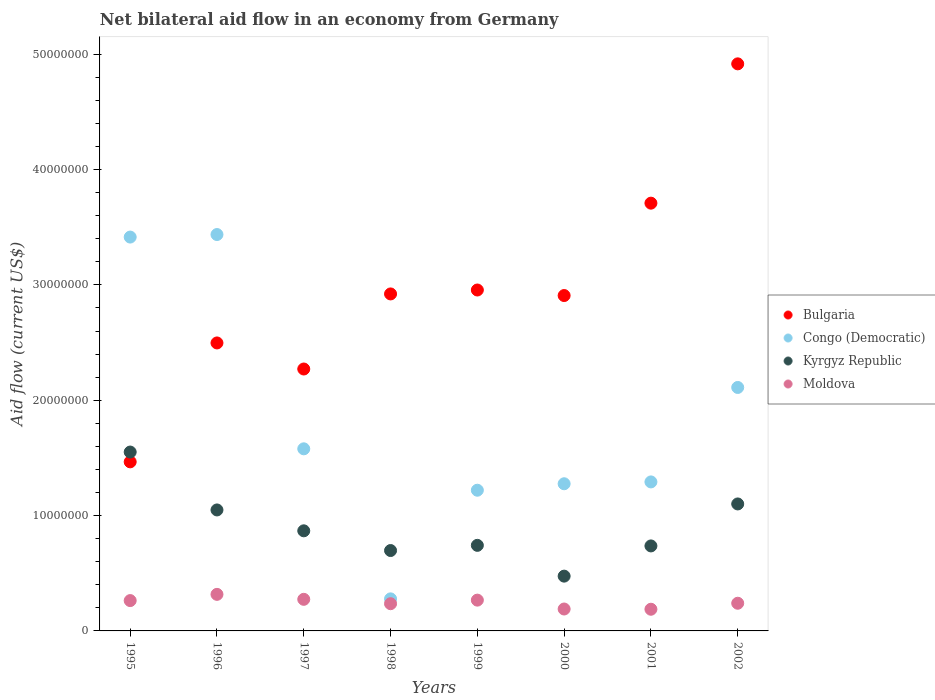What is the net bilateral aid flow in Bulgaria in 1999?
Your answer should be very brief. 2.96e+07. Across all years, what is the maximum net bilateral aid flow in Moldova?
Your response must be concise. 3.17e+06. Across all years, what is the minimum net bilateral aid flow in Congo (Democratic)?
Offer a terse response. 2.78e+06. In which year was the net bilateral aid flow in Moldova minimum?
Keep it short and to the point. 2001. What is the total net bilateral aid flow in Congo (Democratic) in the graph?
Provide a short and direct response. 1.46e+08. What is the difference between the net bilateral aid flow in Congo (Democratic) in 1999 and that in 2000?
Your response must be concise. -5.60e+05. What is the difference between the net bilateral aid flow in Kyrgyz Republic in 2002 and the net bilateral aid flow in Moldova in 2001?
Your response must be concise. 9.13e+06. What is the average net bilateral aid flow in Bulgaria per year?
Offer a terse response. 2.96e+07. In the year 2002, what is the difference between the net bilateral aid flow in Bulgaria and net bilateral aid flow in Kyrgyz Republic?
Give a very brief answer. 3.82e+07. In how many years, is the net bilateral aid flow in Bulgaria greater than 42000000 US$?
Offer a very short reply. 1. What is the ratio of the net bilateral aid flow in Congo (Democratic) in 1999 to that in 2000?
Keep it short and to the point. 0.96. Is the net bilateral aid flow in Kyrgyz Republic in 1995 less than that in 1998?
Make the answer very short. No. What is the difference between the highest and the lowest net bilateral aid flow in Bulgaria?
Provide a short and direct response. 3.45e+07. In how many years, is the net bilateral aid flow in Kyrgyz Republic greater than the average net bilateral aid flow in Kyrgyz Republic taken over all years?
Your answer should be very brief. 3. Is the sum of the net bilateral aid flow in Congo (Democratic) in 1995 and 1997 greater than the maximum net bilateral aid flow in Moldova across all years?
Your answer should be very brief. Yes. Is the net bilateral aid flow in Moldova strictly greater than the net bilateral aid flow in Bulgaria over the years?
Provide a succinct answer. No. Is the net bilateral aid flow in Kyrgyz Republic strictly less than the net bilateral aid flow in Bulgaria over the years?
Give a very brief answer. No. What is the difference between two consecutive major ticks on the Y-axis?
Your answer should be compact. 1.00e+07. How many legend labels are there?
Provide a short and direct response. 4. What is the title of the graph?
Provide a succinct answer. Net bilateral aid flow in an economy from Germany. What is the label or title of the X-axis?
Offer a terse response. Years. What is the Aid flow (current US$) in Bulgaria in 1995?
Your response must be concise. 1.47e+07. What is the Aid flow (current US$) in Congo (Democratic) in 1995?
Offer a very short reply. 3.42e+07. What is the Aid flow (current US$) in Kyrgyz Republic in 1995?
Ensure brevity in your answer.  1.55e+07. What is the Aid flow (current US$) of Moldova in 1995?
Offer a terse response. 2.63e+06. What is the Aid flow (current US$) in Bulgaria in 1996?
Provide a succinct answer. 2.50e+07. What is the Aid flow (current US$) of Congo (Democratic) in 1996?
Offer a very short reply. 3.44e+07. What is the Aid flow (current US$) of Kyrgyz Republic in 1996?
Give a very brief answer. 1.05e+07. What is the Aid flow (current US$) in Moldova in 1996?
Provide a succinct answer. 3.17e+06. What is the Aid flow (current US$) in Bulgaria in 1997?
Ensure brevity in your answer.  2.27e+07. What is the Aid flow (current US$) of Congo (Democratic) in 1997?
Offer a terse response. 1.58e+07. What is the Aid flow (current US$) in Kyrgyz Republic in 1997?
Offer a terse response. 8.68e+06. What is the Aid flow (current US$) in Moldova in 1997?
Your answer should be very brief. 2.74e+06. What is the Aid flow (current US$) in Bulgaria in 1998?
Your response must be concise. 2.92e+07. What is the Aid flow (current US$) in Congo (Democratic) in 1998?
Give a very brief answer. 2.78e+06. What is the Aid flow (current US$) of Kyrgyz Republic in 1998?
Give a very brief answer. 6.97e+06. What is the Aid flow (current US$) of Moldova in 1998?
Your answer should be very brief. 2.36e+06. What is the Aid flow (current US$) of Bulgaria in 1999?
Offer a terse response. 2.96e+07. What is the Aid flow (current US$) of Congo (Democratic) in 1999?
Make the answer very short. 1.22e+07. What is the Aid flow (current US$) in Kyrgyz Republic in 1999?
Your response must be concise. 7.42e+06. What is the Aid flow (current US$) of Moldova in 1999?
Offer a terse response. 2.67e+06. What is the Aid flow (current US$) in Bulgaria in 2000?
Offer a very short reply. 2.91e+07. What is the Aid flow (current US$) in Congo (Democratic) in 2000?
Provide a short and direct response. 1.28e+07. What is the Aid flow (current US$) of Kyrgyz Republic in 2000?
Offer a very short reply. 4.75e+06. What is the Aid flow (current US$) of Moldova in 2000?
Keep it short and to the point. 1.90e+06. What is the Aid flow (current US$) in Bulgaria in 2001?
Keep it short and to the point. 3.71e+07. What is the Aid flow (current US$) of Congo (Democratic) in 2001?
Keep it short and to the point. 1.29e+07. What is the Aid flow (current US$) in Kyrgyz Republic in 2001?
Make the answer very short. 7.37e+06. What is the Aid flow (current US$) in Moldova in 2001?
Your response must be concise. 1.88e+06. What is the Aid flow (current US$) of Bulgaria in 2002?
Your answer should be very brief. 4.92e+07. What is the Aid flow (current US$) in Congo (Democratic) in 2002?
Your answer should be very brief. 2.11e+07. What is the Aid flow (current US$) of Kyrgyz Republic in 2002?
Offer a terse response. 1.10e+07. What is the Aid flow (current US$) of Moldova in 2002?
Give a very brief answer. 2.40e+06. Across all years, what is the maximum Aid flow (current US$) in Bulgaria?
Provide a short and direct response. 4.92e+07. Across all years, what is the maximum Aid flow (current US$) of Congo (Democratic)?
Your response must be concise. 3.44e+07. Across all years, what is the maximum Aid flow (current US$) of Kyrgyz Republic?
Give a very brief answer. 1.55e+07. Across all years, what is the maximum Aid flow (current US$) of Moldova?
Your answer should be compact. 3.17e+06. Across all years, what is the minimum Aid flow (current US$) in Bulgaria?
Make the answer very short. 1.47e+07. Across all years, what is the minimum Aid flow (current US$) of Congo (Democratic)?
Offer a very short reply. 2.78e+06. Across all years, what is the minimum Aid flow (current US$) in Kyrgyz Republic?
Make the answer very short. 4.75e+06. Across all years, what is the minimum Aid flow (current US$) of Moldova?
Offer a terse response. 1.88e+06. What is the total Aid flow (current US$) of Bulgaria in the graph?
Ensure brevity in your answer.  2.36e+08. What is the total Aid flow (current US$) of Congo (Democratic) in the graph?
Provide a short and direct response. 1.46e+08. What is the total Aid flow (current US$) in Kyrgyz Republic in the graph?
Keep it short and to the point. 7.22e+07. What is the total Aid flow (current US$) in Moldova in the graph?
Your answer should be very brief. 1.98e+07. What is the difference between the Aid flow (current US$) of Bulgaria in 1995 and that in 1996?
Offer a terse response. -1.03e+07. What is the difference between the Aid flow (current US$) in Congo (Democratic) in 1995 and that in 1996?
Ensure brevity in your answer.  -2.20e+05. What is the difference between the Aid flow (current US$) in Kyrgyz Republic in 1995 and that in 1996?
Your answer should be compact. 5.02e+06. What is the difference between the Aid flow (current US$) of Moldova in 1995 and that in 1996?
Your response must be concise. -5.40e+05. What is the difference between the Aid flow (current US$) in Bulgaria in 1995 and that in 1997?
Ensure brevity in your answer.  -8.05e+06. What is the difference between the Aid flow (current US$) of Congo (Democratic) in 1995 and that in 1997?
Keep it short and to the point. 1.84e+07. What is the difference between the Aid flow (current US$) of Kyrgyz Republic in 1995 and that in 1997?
Provide a succinct answer. 6.83e+06. What is the difference between the Aid flow (current US$) in Moldova in 1995 and that in 1997?
Give a very brief answer. -1.10e+05. What is the difference between the Aid flow (current US$) in Bulgaria in 1995 and that in 1998?
Provide a succinct answer. -1.46e+07. What is the difference between the Aid flow (current US$) in Congo (Democratic) in 1995 and that in 1998?
Offer a very short reply. 3.14e+07. What is the difference between the Aid flow (current US$) in Kyrgyz Republic in 1995 and that in 1998?
Provide a succinct answer. 8.54e+06. What is the difference between the Aid flow (current US$) of Bulgaria in 1995 and that in 1999?
Make the answer very short. -1.49e+07. What is the difference between the Aid flow (current US$) of Congo (Democratic) in 1995 and that in 1999?
Give a very brief answer. 2.20e+07. What is the difference between the Aid flow (current US$) in Kyrgyz Republic in 1995 and that in 1999?
Your answer should be very brief. 8.09e+06. What is the difference between the Aid flow (current US$) of Moldova in 1995 and that in 1999?
Your response must be concise. -4.00e+04. What is the difference between the Aid flow (current US$) in Bulgaria in 1995 and that in 2000?
Your answer should be very brief. -1.44e+07. What is the difference between the Aid flow (current US$) of Congo (Democratic) in 1995 and that in 2000?
Ensure brevity in your answer.  2.14e+07. What is the difference between the Aid flow (current US$) of Kyrgyz Republic in 1995 and that in 2000?
Offer a terse response. 1.08e+07. What is the difference between the Aid flow (current US$) in Moldova in 1995 and that in 2000?
Give a very brief answer. 7.30e+05. What is the difference between the Aid flow (current US$) in Bulgaria in 1995 and that in 2001?
Your response must be concise. -2.24e+07. What is the difference between the Aid flow (current US$) of Congo (Democratic) in 1995 and that in 2001?
Offer a terse response. 2.12e+07. What is the difference between the Aid flow (current US$) of Kyrgyz Republic in 1995 and that in 2001?
Ensure brevity in your answer.  8.14e+06. What is the difference between the Aid flow (current US$) in Moldova in 1995 and that in 2001?
Give a very brief answer. 7.50e+05. What is the difference between the Aid flow (current US$) in Bulgaria in 1995 and that in 2002?
Your answer should be compact. -3.45e+07. What is the difference between the Aid flow (current US$) in Congo (Democratic) in 1995 and that in 2002?
Keep it short and to the point. 1.30e+07. What is the difference between the Aid flow (current US$) in Kyrgyz Republic in 1995 and that in 2002?
Offer a terse response. 4.50e+06. What is the difference between the Aid flow (current US$) in Bulgaria in 1996 and that in 1997?
Provide a succinct answer. 2.26e+06. What is the difference between the Aid flow (current US$) of Congo (Democratic) in 1996 and that in 1997?
Your answer should be compact. 1.86e+07. What is the difference between the Aid flow (current US$) of Kyrgyz Republic in 1996 and that in 1997?
Your answer should be very brief. 1.81e+06. What is the difference between the Aid flow (current US$) in Bulgaria in 1996 and that in 1998?
Keep it short and to the point. -4.25e+06. What is the difference between the Aid flow (current US$) in Congo (Democratic) in 1996 and that in 1998?
Offer a terse response. 3.16e+07. What is the difference between the Aid flow (current US$) of Kyrgyz Republic in 1996 and that in 1998?
Provide a short and direct response. 3.52e+06. What is the difference between the Aid flow (current US$) of Moldova in 1996 and that in 1998?
Keep it short and to the point. 8.10e+05. What is the difference between the Aid flow (current US$) in Bulgaria in 1996 and that in 1999?
Keep it short and to the point. -4.59e+06. What is the difference between the Aid flow (current US$) in Congo (Democratic) in 1996 and that in 1999?
Your response must be concise. 2.22e+07. What is the difference between the Aid flow (current US$) of Kyrgyz Republic in 1996 and that in 1999?
Give a very brief answer. 3.07e+06. What is the difference between the Aid flow (current US$) in Moldova in 1996 and that in 1999?
Offer a very short reply. 5.00e+05. What is the difference between the Aid flow (current US$) of Bulgaria in 1996 and that in 2000?
Keep it short and to the point. -4.11e+06. What is the difference between the Aid flow (current US$) in Congo (Democratic) in 1996 and that in 2000?
Provide a succinct answer. 2.16e+07. What is the difference between the Aid flow (current US$) in Kyrgyz Republic in 1996 and that in 2000?
Your answer should be very brief. 5.74e+06. What is the difference between the Aid flow (current US$) in Moldova in 1996 and that in 2000?
Provide a short and direct response. 1.27e+06. What is the difference between the Aid flow (current US$) in Bulgaria in 1996 and that in 2001?
Offer a terse response. -1.21e+07. What is the difference between the Aid flow (current US$) of Congo (Democratic) in 1996 and that in 2001?
Ensure brevity in your answer.  2.14e+07. What is the difference between the Aid flow (current US$) of Kyrgyz Republic in 1996 and that in 2001?
Ensure brevity in your answer.  3.12e+06. What is the difference between the Aid flow (current US$) of Moldova in 1996 and that in 2001?
Your response must be concise. 1.29e+06. What is the difference between the Aid flow (current US$) of Bulgaria in 1996 and that in 2002?
Make the answer very short. -2.42e+07. What is the difference between the Aid flow (current US$) in Congo (Democratic) in 1996 and that in 2002?
Offer a very short reply. 1.33e+07. What is the difference between the Aid flow (current US$) of Kyrgyz Republic in 1996 and that in 2002?
Offer a terse response. -5.20e+05. What is the difference between the Aid flow (current US$) of Moldova in 1996 and that in 2002?
Ensure brevity in your answer.  7.70e+05. What is the difference between the Aid flow (current US$) in Bulgaria in 1997 and that in 1998?
Keep it short and to the point. -6.51e+06. What is the difference between the Aid flow (current US$) of Congo (Democratic) in 1997 and that in 1998?
Give a very brief answer. 1.30e+07. What is the difference between the Aid flow (current US$) of Kyrgyz Republic in 1997 and that in 1998?
Provide a succinct answer. 1.71e+06. What is the difference between the Aid flow (current US$) of Bulgaria in 1997 and that in 1999?
Give a very brief answer. -6.85e+06. What is the difference between the Aid flow (current US$) of Congo (Democratic) in 1997 and that in 1999?
Offer a terse response. 3.59e+06. What is the difference between the Aid flow (current US$) in Kyrgyz Republic in 1997 and that in 1999?
Make the answer very short. 1.26e+06. What is the difference between the Aid flow (current US$) of Moldova in 1997 and that in 1999?
Offer a very short reply. 7.00e+04. What is the difference between the Aid flow (current US$) of Bulgaria in 1997 and that in 2000?
Your response must be concise. -6.37e+06. What is the difference between the Aid flow (current US$) of Congo (Democratic) in 1997 and that in 2000?
Keep it short and to the point. 3.03e+06. What is the difference between the Aid flow (current US$) in Kyrgyz Republic in 1997 and that in 2000?
Offer a very short reply. 3.93e+06. What is the difference between the Aid flow (current US$) in Moldova in 1997 and that in 2000?
Your answer should be compact. 8.40e+05. What is the difference between the Aid flow (current US$) in Bulgaria in 1997 and that in 2001?
Provide a short and direct response. -1.44e+07. What is the difference between the Aid flow (current US$) in Congo (Democratic) in 1997 and that in 2001?
Your answer should be very brief. 2.87e+06. What is the difference between the Aid flow (current US$) in Kyrgyz Republic in 1997 and that in 2001?
Offer a terse response. 1.31e+06. What is the difference between the Aid flow (current US$) of Moldova in 1997 and that in 2001?
Offer a terse response. 8.60e+05. What is the difference between the Aid flow (current US$) of Bulgaria in 1997 and that in 2002?
Provide a succinct answer. -2.65e+07. What is the difference between the Aid flow (current US$) of Congo (Democratic) in 1997 and that in 2002?
Your answer should be compact. -5.32e+06. What is the difference between the Aid flow (current US$) of Kyrgyz Republic in 1997 and that in 2002?
Provide a succinct answer. -2.33e+06. What is the difference between the Aid flow (current US$) in Congo (Democratic) in 1998 and that in 1999?
Make the answer very short. -9.42e+06. What is the difference between the Aid flow (current US$) of Kyrgyz Republic in 1998 and that in 1999?
Offer a terse response. -4.50e+05. What is the difference between the Aid flow (current US$) of Moldova in 1998 and that in 1999?
Offer a very short reply. -3.10e+05. What is the difference between the Aid flow (current US$) in Bulgaria in 1998 and that in 2000?
Your answer should be compact. 1.40e+05. What is the difference between the Aid flow (current US$) in Congo (Democratic) in 1998 and that in 2000?
Your answer should be very brief. -9.98e+06. What is the difference between the Aid flow (current US$) in Kyrgyz Republic in 1998 and that in 2000?
Your response must be concise. 2.22e+06. What is the difference between the Aid flow (current US$) in Bulgaria in 1998 and that in 2001?
Your response must be concise. -7.87e+06. What is the difference between the Aid flow (current US$) in Congo (Democratic) in 1998 and that in 2001?
Your answer should be very brief. -1.01e+07. What is the difference between the Aid flow (current US$) in Kyrgyz Republic in 1998 and that in 2001?
Ensure brevity in your answer.  -4.00e+05. What is the difference between the Aid flow (current US$) in Bulgaria in 1998 and that in 2002?
Make the answer very short. -2.00e+07. What is the difference between the Aid flow (current US$) of Congo (Democratic) in 1998 and that in 2002?
Your response must be concise. -1.83e+07. What is the difference between the Aid flow (current US$) in Kyrgyz Republic in 1998 and that in 2002?
Offer a very short reply. -4.04e+06. What is the difference between the Aid flow (current US$) in Moldova in 1998 and that in 2002?
Your answer should be compact. -4.00e+04. What is the difference between the Aid flow (current US$) in Bulgaria in 1999 and that in 2000?
Your response must be concise. 4.80e+05. What is the difference between the Aid flow (current US$) of Congo (Democratic) in 1999 and that in 2000?
Your answer should be compact. -5.60e+05. What is the difference between the Aid flow (current US$) of Kyrgyz Republic in 1999 and that in 2000?
Ensure brevity in your answer.  2.67e+06. What is the difference between the Aid flow (current US$) of Moldova in 1999 and that in 2000?
Make the answer very short. 7.70e+05. What is the difference between the Aid flow (current US$) of Bulgaria in 1999 and that in 2001?
Make the answer very short. -7.53e+06. What is the difference between the Aid flow (current US$) of Congo (Democratic) in 1999 and that in 2001?
Give a very brief answer. -7.20e+05. What is the difference between the Aid flow (current US$) in Kyrgyz Republic in 1999 and that in 2001?
Provide a succinct answer. 5.00e+04. What is the difference between the Aid flow (current US$) of Moldova in 1999 and that in 2001?
Offer a terse response. 7.90e+05. What is the difference between the Aid flow (current US$) in Bulgaria in 1999 and that in 2002?
Make the answer very short. -1.96e+07. What is the difference between the Aid flow (current US$) of Congo (Democratic) in 1999 and that in 2002?
Offer a very short reply. -8.91e+06. What is the difference between the Aid flow (current US$) in Kyrgyz Republic in 1999 and that in 2002?
Make the answer very short. -3.59e+06. What is the difference between the Aid flow (current US$) in Moldova in 1999 and that in 2002?
Offer a very short reply. 2.70e+05. What is the difference between the Aid flow (current US$) of Bulgaria in 2000 and that in 2001?
Give a very brief answer. -8.01e+06. What is the difference between the Aid flow (current US$) of Congo (Democratic) in 2000 and that in 2001?
Provide a succinct answer. -1.60e+05. What is the difference between the Aid flow (current US$) of Kyrgyz Republic in 2000 and that in 2001?
Make the answer very short. -2.62e+06. What is the difference between the Aid flow (current US$) in Bulgaria in 2000 and that in 2002?
Provide a succinct answer. -2.01e+07. What is the difference between the Aid flow (current US$) of Congo (Democratic) in 2000 and that in 2002?
Ensure brevity in your answer.  -8.35e+06. What is the difference between the Aid flow (current US$) in Kyrgyz Republic in 2000 and that in 2002?
Offer a terse response. -6.26e+06. What is the difference between the Aid flow (current US$) of Moldova in 2000 and that in 2002?
Give a very brief answer. -5.00e+05. What is the difference between the Aid flow (current US$) in Bulgaria in 2001 and that in 2002?
Make the answer very short. -1.21e+07. What is the difference between the Aid flow (current US$) of Congo (Democratic) in 2001 and that in 2002?
Offer a very short reply. -8.19e+06. What is the difference between the Aid flow (current US$) in Kyrgyz Republic in 2001 and that in 2002?
Keep it short and to the point. -3.64e+06. What is the difference between the Aid flow (current US$) in Moldova in 2001 and that in 2002?
Your response must be concise. -5.20e+05. What is the difference between the Aid flow (current US$) of Bulgaria in 1995 and the Aid flow (current US$) of Congo (Democratic) in 1996?
Give a very brief answer. -1.97e+07. What is the difference between the Aid flow (current US$) in Bulgaria in 1995 and the Aid flow (current US$) in Kyrgyz Republic in 1996?
Provide a succinct answer. 4.17e+06. What is the difference between the Aid flow (current US$) in Bulgaria in 1995 and the Aid flow (current US$) in Moldova in 1996?
Provide a short and direct response. 1.15e+07. What is the difference between the Aid flow (current US$) in Congo (Democratic) in 1995 and the Aid flow (current US$) in Kyrgyz Republic in 1996?
Your response must be concise. 2.37e+07. What is the difference between the Aid flow (current US$) of Congo (Democratic) in 1995 and the Aid flow (current US$) of Moldova in 1996?
Offer a very short reply. 3.10e+07. What is the difference between the Aid flow (current US$) of Kyrgyz Republic in 1995 and the Aid flow (current US$) of Moldova in 1996?
Make the answer very short. 1.23e+07. What is the difference between the Aid flow (current US$) in Bulgaria in 1995 and the Aid flow (current US$) in Congo (Democratic) in 1997?
Your answer should be compact. -1.13e+06. What is the difference between the Aid flow (current US$) of Bulgaria in 1995 and the Aid flow (current US$) of Kyrgyz Republic in 1997?
Offer a very short reply. 5.98e+06. What is the difference between the Aid flow (current US$) in Bulgaria in 1995 and the Aid flow (current US$) in Moldova in 1997?
Your answer should be compact. 1.19e+07. What is the difference between the Aid flow (current US$) of Congo (Democratic) in 1995 and the Aid flow (current US$) of Kyrgyz Republic in 1997?
Offer a very short reply. 2.55e+07. What is the difference between the Aid flow (current US$) of Congo (Democratic) in 1995 and the Aid flow (current US$) of Moldova in 1997?
Your answer should be very brief. 3.14e+07. What is the difference between the Aid flow (current US$) in Kyrgyz Republic in 1995 and the Aid flow (current US$) in Moldova in 1997?
Ensure brevity in your answer.  1.28e+07. What is the difference between the Aid flow (current US$) in Bulgaria in 1995 and the Aid flow (current US$) in Congo (Democratic) in 1998?
Provide a short and direct response. 1.19e+07. What is the difference between the Aid flow (current US$) of Bulgaria in 1995 and the Aid flow (current US$) of Kyrgyz Republic in 1998?
Provide a succinct answer. 7.69e+06. What is the difference between the Aid flow (current US$) of Bulgaria in 1995 and the Aid flow (current US$) of Moldova in 1998?
Keep it short and to the point. 1.23e+07. What is the difference between the Aid flow (current US$) in Congo (Democratic) in 1995 and the Aid flow (current US$) in Kyrgyz Republic in 1998?
Offer a very short reply. 2.72e+07. What is the difference between the Aid flow (current US$) in Congo (Democratic) in 1995 and the Aid flow (current US$) in Moldova in 1998?
Offer a very short reply. 3.18e+07. What is the difference between the Aid flow (current US$) in Kyrgyz Republic in 1995 and the Aid flow (current US$) in Moldova in 1998?
Give a very brief answer. 1.32e+07. What is the difference between the Aid flow (current US$) of Bulgaria in 1995 and the Aid flow (current US$) of Congo (Democratic) in 1999?
Ensure brevity in your answer.  2.46e+06. What is the difference between the Aid flow (current US$) of Bulgaria in 1995 and the Aid flow (current US$) of Kyrgyz Republic in 1999?
Offer a terse response. 7.24e+06. What is the difference between the Aid flow (current US$) of Bulgaria in 1995 and the Aid flow (current US$) of Moldova in 1999?
Keep it short and to the point. 1.20e+07. What is the difference between the Aid flow (current US$) in Congo (Democratic) in 1995 and the Aid flow (current US$) in Kyrgyz Republic in 1999?
Your answer should be very brief. 2.67e+07. What is the difference between the Aid flow (current US$) in Congo (Democratic) in 1995 and the Aid flow (current US$) in Moldova in 1999?
Ensure brevity in your answer.  3.15e+07. What is the difference between the Aid flow (current US$) in Kyrgyz Republic in 1995 and the Aid flow (current US$) in Moldova in 1999?
Provide a short and direct response. 1.28e+07. What is the difference between the Aid flow (current US$) of Bulgaria in 1995 and the Aid flow (current US$) of Congo (Democratic) in 2000?
Provide a short and direct response. 1.90e+06. What is the difference between the Aid flow (current US$) of Bulgaria in 1995 and the Aid flow (current US$) of Kyrgyz Republic in 2000?
Give a very brief answer. 9.91e+06. What is the difference between the Aid flow (current US$) in Bulgaria in 1995 and the Aid flow (current US$) in Moldova in 2000?
Your response must be concise. 1.28e+07. What is the difference between the Aid flow (current US$) of Congo (Democratic) in 1995 and the Aid flow (current US$) of Kyrgyz Republic in 2000?
Offer a terse response. 2.94e+07. What is the difference between the Aid flow (current US$) in Congo (Democratic) in 1995 and the Aid flow (current US$) in Moldova in 2000?
Offer a terse response. 3.22e+07. What is the difference between the Aid flow (current US$) in Kyrgyz Republic in 1995 and the Aid flow (current US$) in Moldova in 2000?
Make the answer very short. 1.36e+07. What is the difference between the Aid flow (current US$) in Bulgaria in 1995 and the Aid flow (current US$) in Congo (Democratic) in 2001?
Make the answer very short. 1.74e+06. What is the difference between the Aid flow (current US$) in Bulgaria in 1995 and the Aid flow (current US$) in Kyrgyz Republic in 2001?
Offer a terse response. 7.29e+06. What is the difference between the Aid flow (current US$) of Bulgaria in 1995 and the Aid flow (current US$) of Moldova in 2001?
Ensure brevity in your answer.  1.28e+07. What is the difference between the Aid flow (current US$) in Congo (Democratic) in 1995 and the Aid flow (current US$) in Kyrgyz Republic in 2001?
Your response must be concise. 2.68e+07. What is the difference between the Aid flow (current US$) in Congo (Democratic) in 1995 and the Aid flow (current US$) in Moldova in 2001?
Your answer should be compact. 3.23e+07. What is the difference between the Aid flow (current US$) of Kyrgyz Republic in 1995 and the Aid flow (current US$) of Moldova in 2001?
Your answer should be very brief. 1.36e+07. What is the difference between the Aid flow (current US$) in Bulgaria in 1995 and the Aid flow (current US$) in Congo (Democratic) in 2002?
Ensure brevity in your answer.  -6.45e+06. What is the difference between the Aid flow (current US$) in Bulgaria in 1995 and the Aid flow (current US$) in Kyrgyz Republic in 2002?
Make the answer very short. 3.65e+06. What is the difference between the Aid flow (current US$) of Bulgaria in 1995 and the Aid flow (current US$) of Moldova in 2002?
Keep it short and to the point. 1.23e+07. What is the difference between the Aid flow (current US$) of Congo (Democratic) in 1995 and the Aid flow (current US$) of Kyrgyz Republic in 2002?
Give a very brief answer. 2.31e+07. What is the difference between the Aid flow (current US$) in Congo (Democratic) in 1995 and the Aid flow (current US$) in Moldova in 2002?
Offer a very short reply. 3.18e+07. What is the difference between the Aid flow (current US$) in Kyrgyz Republic in 1995 and the Aid flow (current US$) in Moldova in 2002?
Your answer should be very brief. 1.31e+07. What is the difference between the Aid flow (current US$) of Bulgaria in 1996 and the Aid flow (current US$) of Congo (Democratic) in 1997?
Offer a terse response. 9.18e+06. What is the difference between the Aid flow (current US$) of Bulgaria in 1996 and the Aid flow (current US$) of Kyrgyz Republic in 1997?
Provide a short and direct response. 1.63e+07. What is the difference between the Aid flow (current US$) of Bulgaria in 1996 and the Aid flow (current US$) of Moldova in 1997?
Offer a very short reply. 2.22e+07. What is the difference between the Aid flow (current US$) in Congo (Democratic) in 1996 and the Aid flow (current US$) in Kyrgyz Republic in 1997?
Provide a succinct answer. 2.57e+07. What is the difference between the Aid flow (current US$) of Congo (Democratic) in 1996 and the Aid flow (current US$) of Moldova in 1997?
Your answer should be compact. 3.16e+07. What is the difference between the Aid flow (current US$) of Kyrgyz Republic in 1996 and the Aid flow (current US$) of Moldova in 1997?
Give a very brief answer. 7.75e+06. What is the difference between the Aid flow (current US$) of Bulgaria in 1996 and the Aid flow (current US$) of Congo (Democratic) in 1998?
Your answer should be compact. 2.22e+07. What is the difference between the Aid flow (current US$) of Bulgaria in 1996 and the Aid flow (current US$) of Kyrgyz Republic in 1998?
Make the answer very short. 1.80e+07. What is the difference between the Aid flow (current US$) of Bulgaria in 1996 and the Aid flow (current US$) of Moldova in 1998?
Give a very brief answer. 2.26e+07. What is the difference between the Aid flow (current US$) of Congo (Democratic) in 1996 and the Aid flow (current US$) of Kyrgyz Republic in 1998?
Give a very brief answer. 2.74e+07. What is the difference between the Aid flow (current US$) of Congo (Democratic) in 1996 and the Aid flow (current US$) of Moldova in 1998?
Offer a very short reply. 3.20e+07. What is the difference between the Aid flow (current US$) in Kyrgyz Republic in 1996 and the Aid flow (current US$) in Moldova in 1998?
Offer a very short reply. 8.13e+06. What is the difference between the Aid flow (current US$) in Bulgaria in 1996 and the Aid flow (current US$) in Congo (Democratic) in 1999?
Keep it short and to the point. 1.28e+07. What is the difference between the Aid flow (current US$) of Bulgaria in 1996 and the Aid flow (current US$) of Kyrgyz Republic in 1999?
Give a very brief answer. 1.76e+07. What is the difference between the Aid flow (current US$) in Bulgaria in 1996 and the Aid flow (current US$) in Moldova in 1999?
Provide a succinct answer. 2.23e+07. What is the difference between the Aid flow (current US$) of Congo (Democratic) in 1996 and the Aid flow (current US$) of Kyrgyz Republic in 1999?
Ensure brevity in your answer.  2.70e+07. What is the difference between the Aid flow (current US$) in Congo (Democratic) in 1996 and the Aid flow (current US$) in Moldova in 1999?
Provide a succinct answer. 3.17e+07. What is the difference between the Aid flow (current US$) of Kyrgyz Republic in 1996 and the Aid flow (current US$) of Moldova in 1999?
Make the answer very short. 7.82e+06. What is the difference between the Aid flow (current US$) in Bulgaria in 1996 and the Aid flow (current US$) in Congo (Democratic) in 2000?
Offer a very short reply. 1.22e+07. What is the difference between the Aid flow (current US$) of Bulgaria in 1996 and the Aid flow (current US$) of Kyrgyz Republic in 2000?
Provide a short and direct response. 2.02e+07. What is the difference between the Aid flow (current US$) of Bulgaria in 1996 and the Aid flow (current US$) of Moldova in 2000?
Offer a very short reply. 2.31e+07. What is the difference between the Aid flow (current US$) of Congo (Democratic) in 1996 and the Aid flow (current US$) of Kyrgyz Republic in 2000?
Make the answer very short. 2.96e+07. What is the difference between the Aid flow (current US$) of Congo (Democratic) in 1996 and the Aid flow (current US$) of Moldova in 2000?
Ensure brevity in your answer.  3.25e+07. What is the difference between the Aid flow (current US$) of Kyrgyz Republic in 1996 and the Aid flow (current US$) of Moldova in 2000?
Your answer should be very brief. 8.59e+06. What is the difference between the Aid flow (current US$) of Bulgaria in 1996 and the Aid flow (current US$) of Congo (Democratic) in 2001?
Offer a very short reply. 1.20e+07. What is the difference between the Aid flow (current US$) of Bulgaria in 1996 and the Aid flow (current US$) of Kyrgyz Republic in 2001?
Ensure brevity in your answer.  1.76e+07. What is the difference between the Aid flow (current US$) of Bulgaria in 1996 and the Aid flow (current US$) of Moldova in 2001?
Keep it short and to the point. 2.31e+07. What is the difference between the Aid flow (current US$) of Congo (Democratic) in 1996 and the Aid flow (current US$) of Kyrgyz Republic in 2001?
Keep it short and to the point. 2.70e+07. What is the difference between the Aid flow (current US$) in Congo (Democratic) in 1996 and the Aid flow (current US$) in Moldova in 2001?
Ensure brevity in your answer.  3.25e+07. What is the difference between the Aid flow (current US$) in Kyrgyz Republic in 1996 and the Aid flow (current US$) in Moldova in 2001?
Offer a terse response. 8.61e+06. What is the difference between the Aid flow (current US$) in Bulgaria in 1996 and the Aid flow (current US$) in Congo (Democratic) in 2002?
Your answer should be very brief. 3.86e+06. What is the difference between the Aid flow (current US$) in Bulgaria in 1996 and the Aid flow (current US$) in Kyrgyz Republic in 2002?
Provide a succinct answer. 1.40e+07. What is the difference between the Aid flow (current US$) of Bulgaria in 1996 and the Aid flow (current US$) of Moldova in 2002?
Provide a succinct answer. 2.26e+07. What is the difference between the Aid flow (current US$) in Congo (Democratic) in 1996 and the Aid flow (current US$) in Kyrgyz Republic in 2002?
Offer a very short reply. 2.34e+07. What is the difference between the Aid flow (current US$) in Congo (Democratic) in 1996 and the Aid flow (current US$) in Moldova in 2002?
Provide a short and direct response. 3.20e+07. What is the difference between the Aid flow (current US$) in Kyrgyz Republic in 1996 and the Aid flow (current US$) in Moldova in 2002?
Your answer should be compact. 8.09e+06. What is the difference between the Aid flow (current US$) of Bulgaria in 1997 and the Aid flow (current US$) of Congo (Democratic) in 1998?
Offer a terse response. 1.99e+07. What is the difference between the Aid flow (current US$) in Bulgaria in 1997 and the Aid flow (current US$) in Kyrgyz Republic in 1998?
Your answer should be very brief. 1.57e+07. What is the difference between the Aid flow (current US$) in Bulgaria in 1997 and the Aid flow (current US$) in Moldova in 1998?
Your answer should be compact. 2.04e+07. What is the difference between the Aid flow (current US$) of Congo (Democratic) in 1997 and the Aid flow (current US$) of Kyrgyz Republic in 1998?
Ensure brevity in your answer.  8.82e+06. What is the difference between the Aid flow (current US$) in Congo (Democratic) in 1997 and the Aid flow (current US$) in Moldova in 1998?
Make the answer very short. 1.34e+07. What is the difference between the Aid flow (current US$) in Kyrgyz Republic in 1997 and the Aid flow (current US$) in Moldova in 1998?
Keep it short and to the point. 6.32e+06. What is the difference between the Aid flow (current US$) of Bulgaria in 1997 and the Aid flow (current US$) of Congo (Democratic) in 1999?
Make the answer very short. 1.05e+07. What is the difference between the Aid flow (current US$) of Bulgaria in 1997 and the Aid flow (current US$) of Kyrgyz Republic in 1999?
Offer a terse response. 1.53e+07. What is the difference between the Aid flow (current US$) of Bulgaria in 1997 and the Aid flow (current US$) of Moldova in 1999?
Keep it short and to the point. 2.00e+07. What is the difference between the Aid flow (current US$) of Congo (Democratic) in 1997 and the Aid flow (current US$) of Kyrgyz Republic in 1999?
Offer a very short reply. 8.37e+06. What is the difference between the Aid flow (current US$) in Congo (Democratic) in 1997 and the Aid flow (current US$) in Moldova in 1999?
Your response must be concise. 1.31e+07. What is the difference between the Aid flow (current US$) in Kyrgyz Republic in 1997 and the Aid flow (current US$) in Moldova in 1999?
Provide a short and direct response. 6.01e+06. What is the difference between the Aid flow (current US$) of Bulgaria in 1997 and the Aid flow (current US$) of Congo (Democratic) in 2000?
Give a very brief answer. 9.95e+06. What is the difference between the Aid flow (current US$) of Bulgaria in 1997 and the Aid flow (current US$) of Kyrgyz Republic in 2000?
Offer a very short reply. 1.80e+07. What is the difference between the Aid flow (current US$) in Bulgaria in 1997 and the Aid flow (current US$) in Moldova in 2000?
Ensure brevity in your answer.  2.08e+07. What is the difference between the Aid flow (current US$) of Congo (Democratic) in 1997 and the Aid flow (current US$) of Kyrgyz Republic in 2000?
Keep it short and to the point. 1.10e+07. What is the difference between the Aid flow (current US$) of Congo (Democratic) in 1997 and the Aid flow (current US$) of Moldova in 2000?
Provide a succinct answer. 1.39e+07. What is the difference between the Aid flow (current US$) in Kyrgyz Republic in 1997 and the Aid flow (current US$) in Moldova in 2000?
Your answer should be very brief. 6.78e+06. What is the difference between the Aid flow (current US$) of Bulgaria in 1997 and the Aid flow (current US$) of Congo (Democratic) in 2001?
Give a very brief answer. 9.79e+06. What is the difference between the Aid flow (current US$) of Bulgaria in 1997 and the Aid flow (current US$) of Kyrgyz Republic in 2001?
Offer a very short reply. 1.53e+07. What is the difference between the Aid flow (current US$) in Bulgaria in 1997 and the Aid flow (current US$) in Moldova in 2001?
Keep it short and to the point. 2.08e+07. What is the difference between the Aid flow (current US$) in Congo (Democratic) in 1997 and the Aid flow (current US$) in Kyrgyz Republic in 2001?
Make the answer very short. 8.42e+06. What is the difference between the Aid flow (current US$) in Congo (Democratic) in 1997 and the Aid flow (current US$) in Moldova in 2001?
Keep it short and to the point. 1.39e+07. What is the difference between the Aid flow (current US$) in Kyrgyz Republic in 1997 and the Aid flow (current US$) in Moldova in 2001?
Give a very brief answer. 6.80e+06. What is the difference between the Aid flow (current US$) in Bulgaria in 1997 and the Aid flow (current US$) in Congo (Democratic) in 2002?
Give a very brief answer. 1.60e+06. What is the difference between the Aid flow (current US$) in Bulgaria in 1997 and the Aid flow (current US$) in Kyrgyz Republic in 2002?
Make the answer very short. 1.17e+07. What is the difference between the Aid flow (current US$) in Bulgaria in 1997 and the Aid flow (current US$) in Moldova in 2002?
Keep it short and to the point. 2.03e+07. What is the difference between the Aid flow (current US$) in Congo (Democratic) in 1997 and the Aid flow (current US$) in Kyrgyz Republic in 2002?
Your response must be concise. 4.78e+06. What is the difference between the Aid flow (current US$) in Congo (Democratic) in 1997 and the Aid flow (current US$) in Moldova in 2002?
Your answer should be very brief. 1.34e+07. What is the difference between the Aid flow (current US$) in Kyrgyz Republic in 1997 and the Aid flow (current US$) in Moldova in 2002?
Give a very brief answer. 6.28e+06. What is the difference between the Aid flow (current US$) of Bulgaria in 1998 and the Aid flow (current US$) of Congo (Democratic) in 1999?
Provide a succinct answer. 1.70e+07. What is the difference between the Aid flow (current US$) in Bulgaria in 1998 and the Aid flow (current US$) in Kyrgyz Republic in 1999?
Your response must be concise. 2.18e+07. What is the difference between the Aid flow (current US$) of Bulgaria in 1998 and the Aid flow (current US$) of Moldova in 1999?
Provide a succinct answer. 2.66e+07. What is the difference between the Aid flow (current US$) in Congo (Democratic) in 1998 and the Aid flow (current US$) in Kyrgyz Republic in 1999?
Keep it short and to the point. -4.64e+06. What is the difference between the Aid flow (current US$) in Congo (Democratic) in 1998 and the Aid flow (current US$) in Moldova in 1999?
Give a very brief answer. 1.10e+05. What is the difference between the Aid flow (current US$) of Kyrgyz Republic in 1998 and the Aid flow (current US$) of Moldova in 1999?
Your answer should be compact. 4.30e+06. What is the difference between the Aid flow (current US$) in Bulgaria in 1998 and the Aid flow (current US$) in Congo (Democratic) in 2000?
Give a very brief answer. 1.65e+07. What is the difference between the Aid flow (current US$) of Bulgaria in 1998 and the Aid flow (current US$) of Kyrgyz Republic in 2000?
Give a very brief answer. 2.45e+07. What is the difference between the Aid flow (current US$) in Bulgaria in 1998 and the Aid flow (current US$) in Moldova in 2000?
Keep it short and to the point. 2.73e+07. What is the difference between the Aid flow (current US$) in Congo (Democratic) in 1998 and the Aid flow (current US$) in Kyrgyz Republic in 2000?
Provide a short and direct response. -1.97e+06. What is the difference between the Aid flow (current US$) of Congo (Democratic) in 1998 and the Aid flow (current US$) of Moldova in 2000?
Ensure brevity in your answer.  8.80e+05. What is the difference between the Aid flow (current US$) of Kyrgyz Republic in 1998 and the Aid flow (current US$) of Moldova in 2000?
Offer a terse response. 5.07e+06. What is the difference between the Aid flow (current US$) of Bulgaria in 1998 and the Aid flow (current US$) of Congo (Democratic) in 2001?
Offer a very short reply. 1.63e+07. What is the difference between the Aid flow (current US$) in Bulgaria in 1998 and the Aid flow (current US$) in Kyrgyz Republic in 2001?
Your answer should be very brief. 2.18e+07. What is the difference between the Aid flow (current US$) of Bulgaria in 1998 and the Aid flow (current US$) of Moldova in 2001?
Offer a terse response. 2.73e+07. What is the difference between the Aid flow (current US$) in Congo (Democratic) in 1998 and the Aid flow (current US$) in Kyrgyz Republic in 2001?
Give a very brief answer. -4.59e+06. What is the difference between the Aid flow (current US$) in Kyrgyz Republic in 1998 and the Aid flow (current US$) in Moldova in 2001?
Your response must be concise. 5.09e+06. What is the difference between the Aid flow (current US$) of Bulgaria in 1998 and the Aid flow (current US$) of Congo (Democratic) in 2002?
Your answer should be compact. 8.11e+06. What is the difference between the Aid flow (current US$) of Bulgaria in 1998 and the Aid flow (current US$) of Kyrgyz Republic in 2002?
Your answer should be very brief. 1.82e+07. What is the difference between the Aid flow (current US$) in Bulgaria in 1998 and the Aid flow (current US$) in Moldova in 2002?
Provide a short and direct response. 2.68e+07. What is the difference between the Aid flow (current US$) of Congo (Democratic) in 1998 and the Aid flow (current US$) of Kyrgyz Republic in 2002?
Ensure brevity in your answer.  -8.23e+06. What is the difference between the Aid flow (current US$) of Kyrgyz Republic in 1998 and the Aid flow (current US$) of Moldova in 2002?
Your response must be concise. 4.57e+06. What is the difference between the Aid flow (current US$) in Bulgaria in 1999 and the Aid flow (current US$) in Congo (Democratic) in 2000?
Offer a very short reply. 1.68e+07. What is the difference between the Aid flow (current US$) of Bulgaria in 1999 and the Aid flow (current US$) of Kyrgyz Republic in 2000?
Give a very brief answer. 2.48e+07. What is the difference between the Aid flow (current US$) in Bulgaria in 1999 and the Aid flow (current US$) in Moldova in 2000?
Your answer should be compact. 2.77e+07. What is the difference between the Aid flow (current US$) in Congo (Democratic) in 1999 and the Aid flow (current US$) in Kyrgyz Republic in 2000?
Offer a very short reply. 7.45e+06. What is the difference between the Aid flow (current US$) in Congo (Democratic) in 1999 and the Aid flow (current US$) in Moldova in 2000?
Your answer should be very brief. 1.03e+07. What is the difference between the Aid flow (current US$) of Kyrgyz Republic in 1999 and the Aid flow (current US$) of Moldova in 2000?
Make the answer very short. 5.52e+06. What is the difference between the Aid flow (current US$) in Bulgaria in 1999 and the Aid flow (current US$) in Congo (Democratic) in 2001?
Offer a terse response. 1.66e+07. What is the difference between the Aid flow (current US$) in Bulgaria in 1999 and the Aid flow (current US$) in Kyrgyz Republic in 2001?
Your answer should be very brief. 2.22e+07. What is the difference between the Aid flow (current US$) of Bulgaria in 1999 and the Aid flow (current US$) of Moldova in 2001?
Your answer should be compact. 2.77e+07. What is the difference between the Aid flow (current US$) of Congo (Democratic) in 1999 and the Aid flow (current US$) of Kyrgyz Republic in 2001?
Offer a very short reply. 4.83e+06. What is the difference between the Aid flow (current US$) in Congo (Democratic) in 1999 and the Aid flow (current US$) in Moldova in 2001?
Your response must be concise. 1.03e+07. What is the difference between the Aid flow (current US$) of Kyrgyz Republic in 1999 and the Aid flow (current US$) of Moldova in 2001?
Give a very brief answer. 5.54e+06. What is the difference between the Aid flow (current US$) in Bulgaria in 1999 and the Aid flow (current US$) in Congo (Democratic) in 2002?
Keep it short and to the point. 8.45e+06. What is the difference between the Aid flow (current US$) of Bulgaria in 1999 and the Aid flow (current US$) of Kyrgyz Republic in 2002?
Your answer should be compact. 1.86e+07. What is the difference between the Aid flow (current US$) of Bulgaria in 1999 and the Aid flow (current US$) of Moldova in 2002?
Provide a short and direct response. 2.72e+07. What is the difference between the Aid flow (current US$) in Congo (Democratic) in 1999 and the Aid flow (current US$) in Kyrgyz Republic in 2002?
Provide a short and direct response. 1.19e+06. What is the difference between the Aid flow (current US$) in Congo (Democratic) in 1999 and the Aid flow (current US$) in Moldova in 2002?
Ensure brevity in your answer.  9.80e+06. What is the difference between the Aid flow (current US$) of Kyrgyz Republic in 1999 and the Aid flow (current US$) of Moldova in 2002?
Give a very brief answer. 5.02e+06. What is the difference between the Aid flow (current US$) of Bulgaria in 2000 and the Aid flow (current US$) of Congo (Democratic) in 2001?
Give a very brief answer. 1.62e+07. What is the difference between the Aid flow (current US$) in Bulgaria in 2000 and the Aid flow (current US$) in Kyrgyz Republic in 2001?
Keep it short and to the point. 2.17e+07. What is the difference between the Aid flow (current US$) in Bulgaria in 2000 and the Aid flow (current US$) in Moldova in 2001?
Provide a succinct answer. 2.72e+07. What is the difference between the Aid flow (current US$) in Congo (Democratic) in 2000 and the Aid flow (current US$) in Kyrgyz Republic in 2001?
Offer a terse response. 5.39e+06. What is the difference between the Aid flow (current US$) of Congo (Democratic) in 2000 and the Aid flow (current US$) of Moldova in 2001?
Ensure brevity in your answer.  1.09e+07. What is the difference between the Aid flow (current US$) of Kyrgyz Republic in 2000 and the Aid flow (current US$) of Moldova in 2001?
Make the answer very short. 2.87e+06. What is the difference between the Aid flow (current US$) in Bulgaria in 2000 and the Aid flow (current US$) in Congo (Democratic) in 2002?
Provide a short and direct response. 7.97e+06. What is the difference between the Aid flow (current US$) of Bulgaria in 2000 and the Aid flow (current US$) of Kyrgyz Republic in 2002?
Provide a succinct answer. 1.81e+07. What is the difference between the Aid flow (current US$) of Bulgaria in 2000 and the Aid flow (current US$) of Moldova in 2002?
Give a very brief answer. 2.67e+07. What is the difference between the Aid flow (current US$) in Congo (Democratic) in 2000 and the Aid flow (current US$) in Kyrgyz Republic in 2002?
Keep it short and to the point. 1.75e+06. What is the difference between the Aid flow (current US$) of Congo (Democratic) in 2000 and the Aid flow (current US$) of Moldova in 2002?
Your response must be concise. 1.04e+07. What is the difference between the Aid flow (current US$) in Kyrgyz Republic in 2000 and the Aid flow (current US$) in Moldova in 2002?
Give a very brief answer. 2.35e+06. What is the difference between the Aid flow (current US$) in Bulgaria in 2001 and the Aid flow (current US$) in Congo (Democratic) in 2002?
Your answer should be compact. 1.60e+07. What is the difference between the Aid flow (current US$) of Bulgaria in 2001 and the Aid flow (current US$) of Kyrgyz Republic in 2002?
Provide a succinct answer. 2.61e+07. What is the difference between the Aid flow (current US$) in Bulgaria in 2001 and the Aid flow (current US$) in Moldova in 2002?
Your response must be concise. 3.47e+07. What is the difference between the Aid flow (current US$) of Congo (Democratic) in 2001 and the Aid flow (current US$) of Kyrgyz Republic in 2002?
Your answer should be compact. 1.91e+06. What is the difference between the Aid flow (current US$) of Congo (Democratic) in 2001 and the Aid flow (current US$) of Moldova in 2002?
Give a very brief answer. 1.05e+07. What is the difference between the Aid flow (current US$) of Kyrgyz Republic in 2001 and the Aid flow (current US$) of Moldova in 2002?
Provide a short and direct response. 4.97e+06. What is the average Aid flow (current US$) of Bulgaria per year?
Your answer should be compact. 2.96e+07. What is the average Aid flow (current US$) in Congo (Democratic) per year?
Offer a very short reply. 1.83e+07. What is the average Aid flow (current US$) in Kyrgyz Republic per year?
Offer a terse response. 9.02e+06. What is the average Aid flow (current US$) in Moldova per year?
Make the answer very short. 2.47e+06. In the year 1995, what is the difference between the Aid flow (current US$) in Bulgaria and Aid flow (current US$) in Congo (Democratic)?
Keep it short and to the point. -1.95e+07. In the year 1995, what is the difference between the Aid flow (current US$) in Bulgaria and Aid flow (current US$) in Kyrgyz Republic?
Your answer should be very brief. -8.50e+05. In the year 1995, what is the difference between the Aid flow (current US$) in Bulgaria and Aid flow (current US$) in Moldova?
Your answer should be compact. 1.20e+07. In the year 1995, what is the difference between the Aid flow (current US$) of Congo (Democratic) and Aid flow (current US$) of Kyrgyz Republic?
Your response must be concise. 1.86e+07. In the year 1995, what is the difference between the Aid flow (current US$) of Congo (Democratic) and Aid flow (current US$) of Moldova?
Your response must be concise. 3.15e+07. In the year 1995, what is the difference between the Aid flow (current US$) of Kyrgyz Republic and Aid flow (current US$) of Moldova?
Ensure brevity in your answer.  1.29e+07. In the year 1996, what is the difference between the Aid flow (current US$) in Bulgaria and Aid flow (current US$) in Congo (Democratic)?
Provide a succinct answer. -9.40e+06. In the year 1996, what is the difference between the Aid flow (current US$) in Bulgaria and Aid flow (current US$) in Kyrgyz Republic?
Your answer should be compact. 1.45e+07. In the year 1996, what is the difference between the Aid flow (current US$) in Bulgaria and Aid flow (current US$) in Moldova?
Your response must be concise. 2.18e+07. In the year 1996, what is the difference between the Aid flow (current US$) in Congo (Democratic) and Aid flow (current US$) in Kyrgyz Republic?
Offer a terse response. 2.39e+07. In the year 1996, what is the difference between the Aid flow (current US$) in Congo (Democratic) and Aid flow (current US$) in Moldova?
Offer a terse response. 3.12e+07. In the year 1996, what is the difference between the Aid flow (current US$) in Kyrgyz Republic and Aid flow (current US$) in Moldova?
Make the answer very short. 7.32e+06. In the year 1997, what is the difference between the Aid flow (current US$) of Bulgaria and Aid flow (current US$) of Congo (Democratic)?
Keep it short and to the point. 6.92e+06. In the year 1997, what is the difference between the Aid flow (current US$) of Bulgaria and Aid flow (current US$) of Kyrgyz Republic?
Your answer should be compact. 1.40e+07. In the year 1997, what is the difference between the Aid flow (current US$) of Bulgaria and Aid flow (current US$) of Moldova?
Offer a terse response. 2.00e+07. In the year 1997, what is the difference between the Aid flow (current US$) of Congo (Democratic) and Aid flow (current US$) of Kyrgyz Republic?
Your response must be concise. 7.11e+06. In the year 1997, what is the difference between the Aid flow (current US$) of Congo (Democratic) and Aid flow (current US$) of Moldova?
Make the answer very short. 1.30e+07. In the year 1997, what is the difference between the Aid flow (current US$) of Kyrgyz Republic and Aid flow (current US$) of Moldova?
Your answer should be compact. 5.94e+06. In the year 1998, what is the difference between the Aid flow (current US$) in Bulgaria and Aid flow (current US$) in Congo (Democratic)?
Provide a succinct answer. 2.64e+07. In the year 1998, what is the difference between the Aid flow (current US$) in Bulgaria and Aid flow (current US$) in Kyrgyz Republic?
Offer a terse response. 2.22e+07. In the year 1998, what is the difference between the Aid flow (current US$) of Bulgaria and Aid flow (current US$) of Moldova?
Provide a short and direct response. 2.69e+07. In the year 1998, what is the difference between the Aid flow (current US$) of Congo (Democratic) and Aid flow (current US$) of Kyrgyz Republic?
Your response must be concise. -4.19e+06. In the year 1998, what is the difference between the Aid flow (current US$) of Kyrgyz Republic and Aid flow (current US$) of Moldova?
Provide a short and direct response. 4.61e+06. In the year 1999, what is the difference between the Aid flow (current US$) of Bulgaria and Aid flow (current US$) of Congo (Democratic)?
Your answer should be very brief. 1.74e+07. In the year 1999, what is the difference between the Aid flow (current US$) of Bulgaria and Aid flow (current US$) of Kyrgyz Republic?
Offer a very short reply. 2.21e+07. In the year 1999, what is the difference between the Aid flow (current US$) of Bulgaria and Aid flow (current US$) of Moldova?
Give a very brief answer. 2.69e+07. In the year 1999, what is the difference between the Aid flow (current US$) in Congo (Democratic) and Aid flow (current US$) in Kyrgyz Republic?
Provide a short and direct response. 4.78e+06. In the year 1999, what is the difference between the Aid flow (current US$) in Congo (Democratic) and Aid flow (current US$) in Moldova?
Keep it short and to the point. 9.53e+06. In the year 1999, what is the difference between the Aid flow (current US$) of Kyrgyz Republic and Aid flow (current US$) of Moldova?
Give a very brief answer. 4.75e+06. In the year 2000, what is the difference between the Aid flow (current US$) in Bulgaria and Aid flow (current US$) in Congo (Democratic)?
Make the answer very short. 1.63e+07. In the year 2000, what is the difference between the Aid flow (current US$) in Bulgaria and Aid flow (current US$) in Kyrgyz Republic?
Ensure brevity in your answer.  2.43e+07. In the year 2000, what is the difference between the Aid flow (current US$) in Bulgaria and Aid flow (current US$) in Moldova?
Offer a very short reply. 2.72e+07. In the year 2000, what is the difference between the Aid flow (current US$) of Congo (Democratic) and Aid flow (current US$) of Kyrgyz Republic?
Your response must be concise. 8.01e+06. In the year 2000, what is the difference between the Aid flow (current US$) of Congo (Democratic) and Aid flow (current US$) of Moldova?
Your answer should be compact. 1.09e+07. In the year 2000, what is the difference between the Aid flow (current US$) in Kyrgyz Republic and Aid flow (current US$) in Moldova?
Offer a very short reply. 2.85e+06. In the year 2001, what is the difference between the Aid flow (current US$) of Bulgaria and Aid flow (current US$) of Congo (Democratic)?
Provide a succinct answer. 2.42e+07. In the year 2001, what is the difference between the Aid flow (current US$) in Bulgaria and Aid flow (current US$) in Kyrgyz Republic?
Provide a short and direct response. 2.97e+07. In the year 2001, what is the difference between the Aid flow (current US$) of Bulgaria and Aid flow (current US$) of Moldova?
Your answer should be very brief. 3.52e+07. In the year 2001, what is the difference between the Aid flow (current US$) of Congo (Democratic) and Aid flow (current US$) of Kyrgyz Republic?
Provide a short and direct response. 5.55e+06. In the year 2001, what is the difference between the Aid flow (current US$) in Congo (Democratic) and Aid flow (current US$) in Moldova?
Offer a terse response. 1.10e+07. In the year 2001, what is the difference between the Aid flow (current US$) of Kyrgyz Republic and Aid flow (current US$) of Moldova?
Your response must be concise. 5.49e+06. In the year 2002, what is the difference between the Aid flow (current US$) of Bulgaria and Aid flow (current US$) of Congo (Democratic)?
Ensure brevity in your answer.  2.81e+07. In the year 2002, what is the difference between the Aid flow (current US$) of Bulgaria and Aid flow (current US$) of Kyrgyz Republic?
Your answer should be very brief. 3.82e+07. In the year 2002, what is the difference between the Aid flow (current US$) of Bulgaria and Aid flow (current US$) of Moldova?
Your response must be concise. 4.68e+07. In the year 2002, what is the difference between the Aid flow (current US$) in Congo (Democratic) and Aid flow (current US$) in Kyrgyz Republic?
Give a very brief answer. 1.01e+07. In the year 2002, what is the difference between the Aid flow (current US$) in Congo (Democratic) and Aid flow (current US$) in Moldova?
Ensure brevity in your answer.  1.87e+07. In the year 2002, what is the difference between the Aid flow (current US$) in Kyrgyz Republic and Aid flow (current US$) in Moldova?
Your answer should be very brief. 8.61e+06. What is the ratio of the Aid flow (current US$) of Bulgaria in 1995 to that in 1996?
Ensure brevity in your answer.  0.59. What is the ratio of the Aid flow (current US$) in Kyrgyz Republic in 1995 to that in 1996?
Your answer should be compact. 1.48. What is the ratio of the Aid flow (current US$) of Moldova in 1995 to that in 1996?
Keep it short and to the point. 0.83. What is the ratio of the Aid flow (current US$) in Bulgaria in 1995 to that in 1997?
Your answer should be compact. 0.65. What is the ratio of the Aid flow (current US$) of Congo (Democratic) in 1995 to that in 1997?
Your answer should be very brief. 2.16. What is the ratio of the Aid flow (current US$) in Kyrgyz Republic in 1995 to that in 1997?
Your response must be concise. 1.79. What is the ratio of the Aid flow (current US$) in Moldova in 1995 to that in 1997?
Keep it short and to the point. 0.96. What is the ratio of the Aid flow (current US$) of Bulgaria in 1995 to that in 1998?
Keep it short and to the point. 0.5. What is the ratio of the Aid flow (current US$) in Congo (Democratic) in 1995 to that in 1998?
Make the answer very short. 12.28. What is the ratio of the Aid flow (current US$) in Kyrgyz Republic in 1995 to that in 1998?
Provide a succinct answer. 2.23. What is the ratio of the Aid flow (current US$) in Moldova in 1995 to that in 1998?
Your response must be concise. 1.11. What is the ratio of the Aid flow (current US$) of Bulgaria in 1995 to that in 1999?
Ensure brevity in your answer.  0.5. What is the ratio of the Aid flow (current US$) in Congo (Democratic) in 1995 to that in 1999?
Offer a terse response. 2.8. What is the ratio of the Aid flow (current US$) of Kyrgyz Republic in 1995 to that in 1999?
Your answer should be very brief. 2.09. What is the ratio of the Aid flow (current US$) of Moldova in 1995 to that in 1999?
Give a very brief answer. 0.98. What is the ratio of the Aid flow (current US$) of Bulgaria in 1995 to that in 2000?
Ensure brevity in your answer.  0.5. What is the ratio of the Aid flow (current US$) of Congo (Democratic) in 1995 to that in 2000?
Provide a succinct answer. 2.68. What is the ratio of the Aid flow (current US$) in Kyrgyz Republic in 1995 to that in 2000?
Make the answer very short. 3.27. What is the ratio of the Aid flow (current US$) of Moldova in 1995 to that in 2000?
Provide a succinct answer. 1.38. What is the ratio of the Aid flow (current US$) in Bulgaria in 1995 to that in 2001?
Offer a terse response. 0.4. What is the ratio of the Aid flow (current US$) in Congo (Democratic) in 1995 to that in 2001?
Offer a terse response. 2.64. What is the ratio of the Aid flow (current US$) in Kyrgyz Republic in 1995 to that in 2001?
Provide a short and direct response. 2.1. What is the ratio of the Aid flow (current US$) in Moldova in 1995 to that in 2001?
Ensure brevity in your answer.  1.4. What is the ratio of the Aid flow (current US$) of Bulgaria in 1995 to that in 2002?
Provide a short and direct response. 0.3. What is the ratio of the Aid flow (current US$) in Congo (Democratic) in 1995 to that in 2002?
Keep it short and to the point. 1.62. What is the ratio of the Aid flow (current US$) in Kyrgyz Republic in 1995 to that in 2002?
Keep it short and to the point. 1.41. What is the ratio of the Aid flow (current US$) of Moldova in 1995 to that in 2002?
Offer a terse response. 1.1. What is the ratio of the Aid flow (current US$) in Bulgaria in 1996 to that in 1997?
Provide a short and direct response. 1.1. What is the ratio of the Aid flow (current US$) of Congo (Democratic) in 1996 to that in 1997?
Offer a very short reply. 2.18. What is the ratio of the Aid flow (current US$) of Kyrgyz Republic in 1996 to that in 1997?
Give a very brief answer. 1.21. What is the ratio of the Aid flow (current US$) in Moldova in 1996 to that in 1997?
Offer a very short reply. 1.16. What is the ratio of the Aid flow (current US$) in Bulgaria in 1996 to that in 1998?
Your answer should be very brief. 0.85. What is the ratio of the Aid flow (current US$) in Congo (Democratic) in 1996 to that in 1998?
Your answer should be very brief. 12.36. What is the ratio of the Aid flow (current US$) in Kyrgyz Republic in 1996 to that in 1998?
Your answer should be compact. 1.5. What is the ratio of the Aid flow (current US$) in Moldova in 1996 to that in 1998?
Offer a terse response. 1.34. What is the ratio of the Aid flow (current US$) of Bulgaria in 1996 to that in 1999?
Your response must be concise. 0.84. What is the ratio of the Aid flow (current US$) in Congo (Democratic) in 1996 to that in 1999?
Offer a very short reply. 2.82. What is the ratio of the Aid flow (current US$) in Kyrgyz Republic in 1996 to that in 1999?
Your answer should be compact. 1.41. What is the ratio of the Aid flow (current US$) of Moldova in 1996 to that in 1999?
Your answer should be compact. 1.19. What is the ratio of the Aid flow (current US$) in Bulgaria in 1996 to that in 2000?
Offer a very short reply. 0.86. What is the ratio of the Aid flow (current US$) of Congo (Democratic) in 1996 to that in 2000?
Offer a terse response. 2.69. What is the ratio of the Aid flow (current US$) in Kyrgyz Republic in 1996 to that in 2000?
Offer a very short reply. 2.21. What is the ratio of the Aid flow (current US$) of Moldova in 1996 to that in 2000?
Your response must be concise. 1.67. What is the ratio of the Aid flow (current US$) of Bulgaria in 1996 to that in 2001?
Your answer should be very brief. 0.67. What is the ratio of the Aid flow (current US$) of Congo (Democratic) in 1996 to that in 2001?
Ensure brevity in your answer.  2.66. What is the ratio of the Aid flow (current US$) of Kyrgyz Republic in 1996 to that in 2001?
Offer a terse response. 1.42. What is the ratio of the Aid flow (current US$) of Moldova in 1996 to that in 2001?
Give a very brief answer. 1.69. What is the ratio of the Aid flow (current US$) in Bulgaria in 1996 to that in 2002?
Give a very brief answer. 0.51. What is the ratio of the Aid flow (current US$) of Congo (Democratic) in 1996 to that in 2002?
Your response must be concise. 1.63. What is the ratio of the Aid flow (current US$) of Kyrgyz Republic in 1996 to that in 2002?
Your response must be concise. 0.95. What is the ratio of the Aid flow (current US$) of Moldova in 1996 to that in 2002?
Make the answer very short. 1.32. What is the ratio of the Aid flow (current US$) of Bulgaria in 1997 to that in 1998?
Provide a succinct answer. 0.78. What is the ratio of the Aid flow (current US$) of Congo (Democratic) in 1997 to that in 1998?
Offer a very short reply. 5.68. What is the ratio of the Aid flow (current US$) in Kyrgyz Republic in 1997 to that in 1998?
Give a very brief answer. 1.25. What is the ratio of the Aid flow (current US$) in Moldova in 1997 to that in 1998?
Provide a succinct answer. 1.16. What is the ratio of the Aid flow (current US$) of Bulgaria in 1997 to that in 1999?
Your answer should be very brief. 0.77. What is the ratio of the Aid flow (current US$) in Congo (Democratic) in 1997 to that in 1999?
Make the answer very short. 1.29. What is the ratio of the Aid flow (current US$) in Kyrgyz Republic in 1997 to that in 1999?
Offer a terse response. 1.17. What is the ratio of the Aid flow (current US$) in Moldova in 1997 to that in 1999?
Your answer should be compact. 1.03. What is the ratio of the Aid flow (current US$) in Bulgaria in 1997 to that in 2000?
Keep it short and to the point. 0.78. What is the ratio of the Aid flow (current US$) of Congo (Democratic) in 1997 to that in 2000?
Ensure brevity in your answer.  1.24. What is the ratio of the Aid flow (current US$) in Kyrgyz Republic in 1997 to that in 2000?
Keep it short and to the point. 1.83. What is the ratio of the Aid flow (current US$) in Moldova in 1997 to that in 2000?
Ensure brevity in your answer.  1.44. What is the ratio of the Aid flow (current US$) in Bulgaria in 1997 to that in 2001?
Offer a very short reply. 0.61. What is the ratio of the Aid flow (current US$) of Congo (Democratic) in 1997 to that in 2001?
Offer a very short reply. 1.22. What is the ratio of the Aid flow (current US$) in Kyrgyz Republic in 1997 to that in 2001?
Give a very brief answer. 1.18. What is the ratio of the Aid flow (current US$) in Moldova in 1997 to that in 2001?
Your answer should be very brief. 1.46. What is the ratio of the Aid flow (current US$) of Bulgaria in 1997 to that in 2002?
Offer a very short reply. 0.46. What is the ratio of the Aid flow (current US$) of Congo (Democratic) in 1997 to that in 2002?
Provide a short and direct response. 0.75. What is the ratio of the Aid flow (current US$) of Kyrgyz Republic in 1997 to that in 2002?
Your answer should be compact. 0.79. What is the ratio of the Aid flow (current US$) in Moldova in 1997 to that in 2002?
Your response must be concise. 1.14. What is the ratio of the Aid flow (current US$) of Bulgaria in 1998 to that in 1999?
Your answer should be very brief. 0.99. What is the ratio of the Aid flow (current US$) of Congo (Democratic) in 1998 to that in 1999?
Provide a short and direct response. 0.23. What is the ratio of the Aid flow (current US$) in Kyrgyz Republic in 1998 to that in 1999?
Offer a very short reply. 0.94. What is the ratio of the Aid flow (current US$) in Moldova in 1998 to that in 1999?
Your response must be concise. 0.88. What is the ratio of the Aid flow (current US$) in Congo (Democratic) in 1998 to that in 2000?
Keep it short and to the point. 0.22. What is the ratio of the Aid flow (current US$) of Kyrgyz Republic in 1998 to that in 2000?
Keep it short and to the point. 1.47. What is the ratio of the Aid flow (current US$) of Moldova in 1998 to that in 2000?
Give a very brief answer. 1.24. What is the ratio of the Aid flow (current US$) of Bulgaria in 1998 to that in 2001?
Make the answer very short. 0.79. What is the ratio of the Aid flow (current US$) of Congo (Democratic) in 1998 to that in 2001?
Provide a short and direct response. 0.22. What is the ratio of the Aid flow (current US$) in Kyrgyz Republic in 1998 to that in 2001?
Keep it short and to the point. 0.95. What is the ratio of the Aid flow (current US$) of Moldova in 1998 to that in 2001?
Your answer should be very brief. 1.26. What is the ratio of the Aid flow (current US$) in Bulgaria in 1998 to that in 2002?
Make the answer very short. 0.59. What is the ratio of the Aid flow (current US$) in Congo (Democratic) in 1998 to that in 2002?
Make the answer very short. 0.13. What is the ratio of the Aid flow (current US$) of Kyrgyz Republic in 1998 to that in 2002?
Offer a very short reply. 0.63. What is the ratio of the Aid flow (current US$) in Moldova in 1998 to that in 2002?
Your answer should be compact. 0.98. What is the ratio of the Aid flow (current US$) in Bulgaria in 1999 to that in 2000?
Your answer should be very brief. 1.02. What is the ratio of the Aid flow (current US$) in Congo (Democratic) in 1999 to that in 2000?
Ensure brevity in your answer.  0.96. What is the ratio of the Aid flow (current US$) in Kyrgyz Republic in 1999 to that in 2000?
Offer a terse response. 1.56. What is the ratio of the Aid flow (current US$) in Moldova in 1999 to that in 2000?
Keep it short and to the point. 1.41. What is the ratio of the Aid flow (current US$) in Bulgaria in 1999 to that in 2001?
Provide a succinct answer. 0.8. What is the ratio of the Aid flow (current US$) in Congo (Democratic) in 1999 to that in 2001?
Offer a very short reply. 0.94. What is the ratio of the Aid flow (current US$) in Kyrgyz Republic in 1999 to that in 2001?
Your response must be concise. 1.01. What is the ratio of the Aid flow (current US$) of Moldova in 1999 to that in 2001?
Your response must be concise. 1.42. What is the ratio of the Aid flow (current US$) in Bulgaria in 1999 to that in 2002?
Keep it short and to the point. 0.6. What is the ratio of the Aid flow (current US$) in Congo (Democratic) in 1999 to that in 2002?
Keep it short and to the point. 0.58. What is the ratio of the Aid flow (current US$) of Kyrgyz Republic in 1999 to that in 2002?
Your answer should be very brief. 0.67. What is the ratio of the Aid flow (current US$) in Moldova in 1999 to that in 2002?
Keep it short and to the point. 1.11. What is the ratio of the Aid flow (current US$) in Bulgaria in 2000 to that in 2001?
Provide a succinct answer. 0.78. What is the ratio of the Aid flow (current US$) of Congo (Democratic) in 2000 to that in 2001?
Give a very brief answer. 0.99. What is the ratio of the Aid flow (current US$) of Kyrgyz Republic in 2000 to that in 2001?
Provide a succinct answer. 0.64. What is the ratio of the Aid flow (current US$) of Moldova in 2000 to that in 2001?
Ensure brevity in your answer.  1.01. What is the ratio of the Aid flow (current US$) in Bulgaria in 2000 to that in 2002?
Make the answer very short. 0.59. What is the ratio of the Aid flow (current US$) in Congo (Democratic) in 2000 to that in 2002?
Ensure brevity in your answer.  0.6. What is the ratio of the Aid flow (current US$) of Kyrgyz Republic in 2000 to that in 2002?
Provide a short and direct response. 0.43. What is the ratio of the Aid flow (current US$) of Moldova in 2000 to that in 2002?
Give a very brief answer. 0.79. What is the ratio of the Aid flow (current US$) of Bulgaria in 2001 to that in 2002?
Ensure brevity in your answer.  0.75. What is the ratio of the Aid flow (current US$) in Congo (Democratic) in 2001 to that in 2002?
Make the answer very short. 0.61. What is the ratio of the Aid flow (current US$) of Kyrgyz Republic in 2001 to that in 2002?
Your answer should be very brief. 0.67. What is the ratio of the Aid flow (current US$) of Moldova in 2001 to that in 2002?
Offer a very short reply. 0.78. What is the difference between the highest and the second highest Aid flow (current US$) of Bulgaria?
Your answer should be compact. 1.21e+07. What is the difference between the highest and the second highest Aid flow (current US$) of Kyrgyz Republic?
Keep it short and to the point. 4.50e+06. What is the difference between the highest and the second highest Aid flow (current US$) in Moldova?
Give a very brief answer. 4.30e+05. What is the difference between the highest and the lowest Aid flow (current US$) in Bulgaria?
Provide a succinct answer. 3.45e+07. What is the difference between the highest and the lowest Aid flow (current US$) of Congo (Democratic)?
Offer a very short reply. 3.16e+07. What is the difference between the highest and the lowest Aid flow (current US$) of Kyrgyz Republic?
Offer a terse response. 1.08e+07. What is the difference between the highest and the lowest Aid flow (current US$) in Moldova?
Offer a terse response. 1.29e+06. 